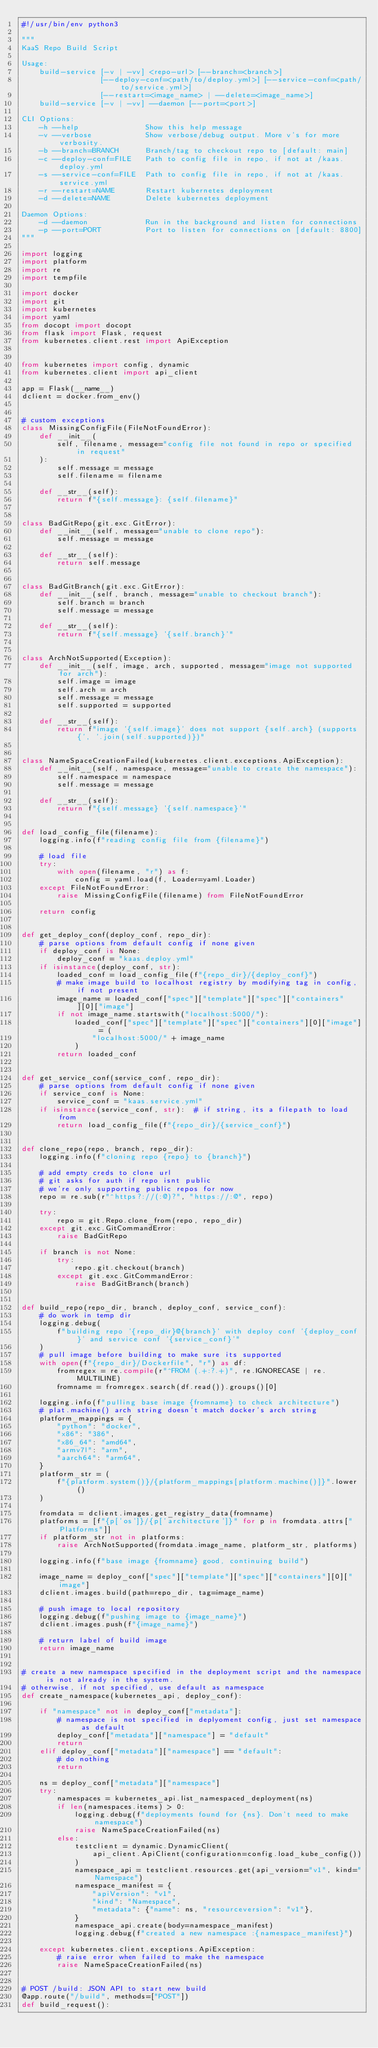Convert code to text. <code><loc_0><loc_0><loc_500><loc_500><_Python_>#!/usr/bin/env python3

"""
KaaS Repo Build Script

Usage:
    build-service [-v | -vv] <repo-url> [--branch=<branch>]
                  [--deploy-conf=<path/to/deploy.yml>] [--service-conf=<path/to/service.yml>]
                  [--restart=<image_name> | --delete=<image_name>]
    build-service [-v | -vv] --daemon [--port=<port>]

CLI Options:
    -h --help               Show this help message
    -v --verbose            Show verbose/debug output. More v's for more verbosity.
    -b --branch=BRANCH      Branch/tag to checkout repo to [default: main]
    -c --deploy-conf=FILE   Path to config file in repo, if not at /kaas.deploy.yml
    -s --service-conf=FILE  Path to config file in repo, if not at /kaas.service.yml
    -r --restart=NAME       Restart kubernetes deployment
    -d --delete=NAME        Delete kubernetes deployment

Daemon Options:
    -d --daemon             Run in the background and listen for connections
    -p --port=PORT          Port to listen for connections on [default: 8800]
"""

import logging
import platform
import re
import tempfile

import docker
import git
import kubernetes
import yaml
from docopt import docopt
from flask import Flask, request
from kubernetes.client.rest import ApiException


from kubernetes import config, dynamic
from kubernetes.client import api_client

app = Flask(__name__)
dclient = docker.from_env()


# custom exceptions
class MissingConfigFile(FileNotFoundError):
    def __init__(
        self, filename, message="config file not found in repo or specified in request"
    ):
        self.message = message
        self.filename = filename

    def __str__(self):
        return f"{self.message}: {self.filename}"


class BadGitRepo(git.exc.GitError):
    def __init__(self, message="unable to clone repo"):
        self.message = message

    def __str__(self):
        return self.message


class BadGitBranch(git.exc.GitError):
    def __init__(self, branch, message="unable to checkout branch"):
        self.branch = branch
        self.message = message

    def __str__(self):
        return f"{self.message} '{self.branch}'"


class ArchNotSupported(Exception):
    def __init__(self, image, arch, supported, message="image not supported for arch"):
        self.image = image
        self.arch = arch
        self.message = message
        self.supported = supported

    def __str__(self):
        return f"image '{self.image}' does not support {self.arch} (supports {', '.join(self.supported)})"


class NameSpaceCreationFailed(kubernetes.client.exceptions.ApiException):
    def __init__(self, namespace, message="unable to create the namespace"):
        self.namespace = namespace
        self.message = message

    def __str__(self):
        return f"{self.message} '{self.namespace}'"


def load_config_file(filename):
    logging.info(f"reading config file from {filename}")

    # load file
    try:
        with open(filename, "r") as f:
            config = yaml.load(f, Loader=yaml.Loader)
    except FileNotFoundError:
        raise MissingConfigFile(filename) from FileNotFoundError

    return config


def get_deploy_conf(deploy_conf, repo_dir):
    # parse options from default config if none given
    if deploy_conf is None:
        deploy_conf = "kaas.deploy.yml"
    if isinstance(deploy_conf, str):
        loaded_conf = load_config_file(f"{repo_dir}/{deploy_conf}")
        # make image build to localhost registry by modifying tag in config, if not present
        image_name = loaded_conf["spec"]["template"]["spec"]["containers"][0]["image"]
        if not image_name.startswith("localhost:5000/"):
            loaded_conf["spec"]["template"]["spec"]["containers"][0]["image"] = (
                "localhost:5000/" + image_name
            )
        return loaded_conf


def get_service_conf(service_conf, repo_dir):
    # parse options from default config if none given
    if service_conf is None:
        service_conf = "kaas.service.yml"
    if isinstance(service_conf, str):  # if string, its a filepath to load from
        return load_config_file(f"{repo_dir}/{service_conf}")


def clone_repo(repo, branch, repo_dir):
    logging.info(f"cloning repo {repo} to {branch}")

    # add empty creds to clone url
    # git asks for auth if repo isnt public
    # we're only supporting public repos for now
    repo = re.sub(r"^https?://(:@)?", "https://:@", repo)

    try:
        repo = git.Repo.clone_from(repo, repo_dir)
    except git.exc.GitCommandError:
        raise BadGitRepo

    if branch is not None:
        try:
            repo.git.checkout(branch)
        except git.exc.GitCommandError:
            raise BadGitBranch(branch)


def build_repo(repo_dir, branch, deploy_conf, service_conf):
    # do work in temp dir
    logging.debug(
        f"building repo '{repo_dir}@{branch}' with deploy conf '{deploy_conf}' and service conf '{service_conf}'"
    )
    # pull image before building to make sure its supported
    with open(f"{repo_dir}/Dockerfile", "r") as df:
        fromregex = re.compile(r"^FROM (.+:?.+)", re.IGNORECASE | re.MULTILINE)
        fromname = fromregex.search(df.read()).groups()[0]

    logging.info(f"pulling base image {fromname} to check architecture")
    # plat.machine() arch string doesn't match docker's arch string
    platform_mappings = {
        "python": "docker",
        "x86": "386",
        "x86_64": "amd64",
        "armv7l": "arm",
        "aarch64": "arm64",
    }
    platform_str = (
        f"{platform.system()}/{platform_mappings[platform.machine()]}".lower()
    )

    fromdata = dclient.images.get_registry_data(fromname)
    platforms = [f"{p['os']}/{p['architecture']}" for p in fromdata.attrs["Platforms"]]
    if platform_str not in platforms:
        raise ArchNotSupported(fromdata.image_name, platform_str, platforms)

    logging.info(f"base image {fromname} good, continuing build")

    image_name = deploy_conf["spec"]["template"]["spec"]["containers"][0]["image"]
    dclient.images.build(path=repo_dir, tag=image_name)

    # push image to local repository
    logging.debug(f"pushing image to {image_name}")
    dclient.images.push(f"{image_name}")

    # return label of build image
    return image_name


# create a new namespace specified in the deployment script and the namespace is not already in the system.
# otherwise, if not specified, use default as namespace
def create_namespace(kubernetes_api, deploy_conf):

    if "namespace" not in deploy_conf["metadata"]:
        # namespace is not specified in deplyoment config, just set namespace as default
        deploy_conf["metadata"]["namespace"] = "default"
        return
    elif deploy_conf["metadata"]["namespace"] == "default":
        # do nothing
        return

    ns = deploy_conf["metadata"]["namespace"]
    try:
        namespaces = kubernetes_api.list_namespaced_deployment(ns)
        if len(namespaces.items) > 0:
            logging.debug(f"deployments found for {ns}. Don't need to make namespace")
            raise NameSpaceCreationFailed(ns)
        else:
            testclient = dynamic.DynamicClient(
                api_client.ApiClient(configuration=config.load_kube_config())
            )
            namespace_api = testclient.resources.get(api_version="v1", kind="Namespace")
            namespace_manifest = {
                "apiVersion": "v1",
                "kind": "Namespace",
                "metadata": {"name": ns, "resourceversion": "v1"},
            }
            namespace_api.create(body=namespace_manifest)
            logging.debug(f"created a new namespace :{namespace_manifest}")

    except kubernetes.client.exceptions.ApiException:
        # raise error when failed to make the namespace
        raise NameSpaceCreationFailed(ns)


# POST /build: JSON API to start new build
@app.route("/build", methods=["POST"])
def build_request():</code> 